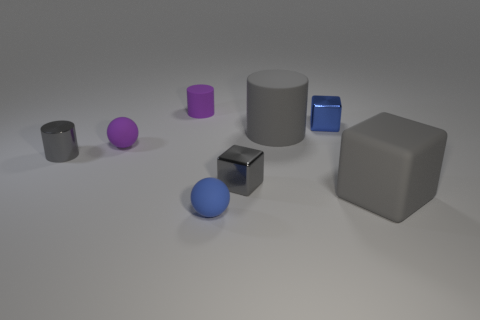Subtract all large cylinders. How many cylinders are left? 2 Subtract all blue cubes. How many cubes are left? 2 Add 1 blue cubes. How many objects exist? 9 Subtract all cylinders. How many objects are left? 5 Subtract all green cylinders. Subtract all purple balls. How many cylinders are left? 3 Subtract all red spheres. How many gray cylinders are left? 2 Subtract 2 gray cylinders. How many objects are left? 6 Subtract 1 spheres. How many spheres are left? 1 Subtract all small gray metal cylinders. Subtract all large gray metal things. How many objects are left? 7 Add 2 shiny cubes. How many shiny cubes are left? 4 